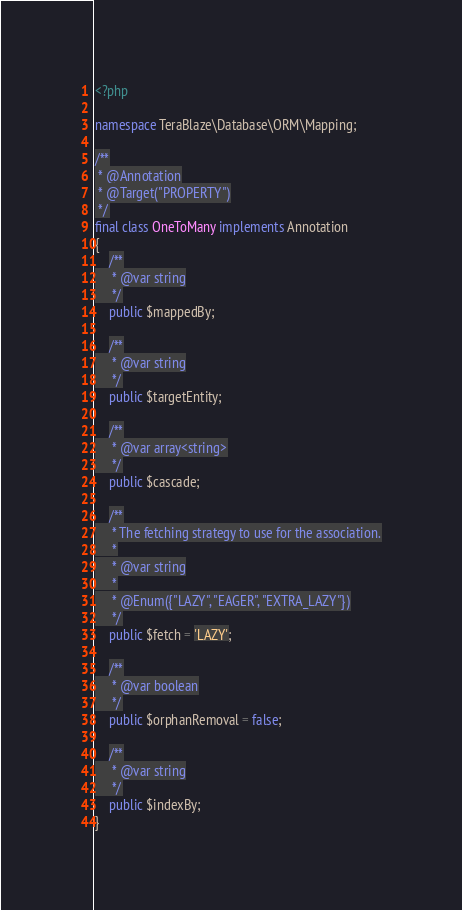Convert code to text. <code><loc_0><loc_0><loc_500><loc_500><_PHP_><?php

namespace TeraBlaze\Database\ORM\Mapping;

/**
 * @Annotation
 * @Target("PROPERTY")
 */
final class OneToMany implements Annotation
{
    /**
     * @var string
     */
    public $mappedBy;

    /**
     * @var string
     */
    public $targetEntity;

    /**
     * @var array<string>
     */
    public $cascade;

    /**
     * The fetching strategy to use for the association.
     *
     * @var string
     *
     * @Enum({"LAZY", "EAGER", "EXTRA_LAZY"})
     */
    public $fetch = 'LAZY';

    /**
     * @var boolean
     */
    public $orphanRemoval = false;

    /**
     * @var string
     */
    public $indexBy;
}
</code> 